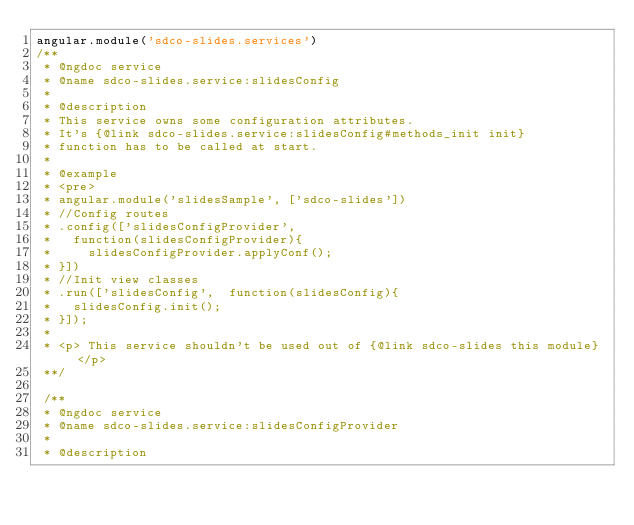<code> <loc_0><loc_0><loc_500><loc_500><_JavaScript_>angular.module('sdco-slides.services')
/**
 * @ngdoc service
 * @name sdco-slides.service:slidesConfig
 *
 * @description
 * This service owns some configuration attributes.
 * It's {@link sdco-slides.service:slidesConfig#methods_init init}
 * function has to be called at start.
 * 
 * @example
 * <pre>
 * angular.module('slidesSample', ['sdco-slides'])
 * //Config routes
 * .config(['slidesConfigProvider',
 *   function(slidesConfigProvider){
 *     slidesConfigProvider.applyConf();
 * }])
 * //Init view classes
 * .run(['slidesConfig',  function(slidesConfig){
 *   slidesConfig.init();
 * }]);
 *
 * <p> This service shouldn't be used out of {@link sdco-slides this module} </p>
 **/

 /**
 * @ngdoc service
 * @name sdco-slides.service:slidesConfigProvider
 *
 * @description</code> 